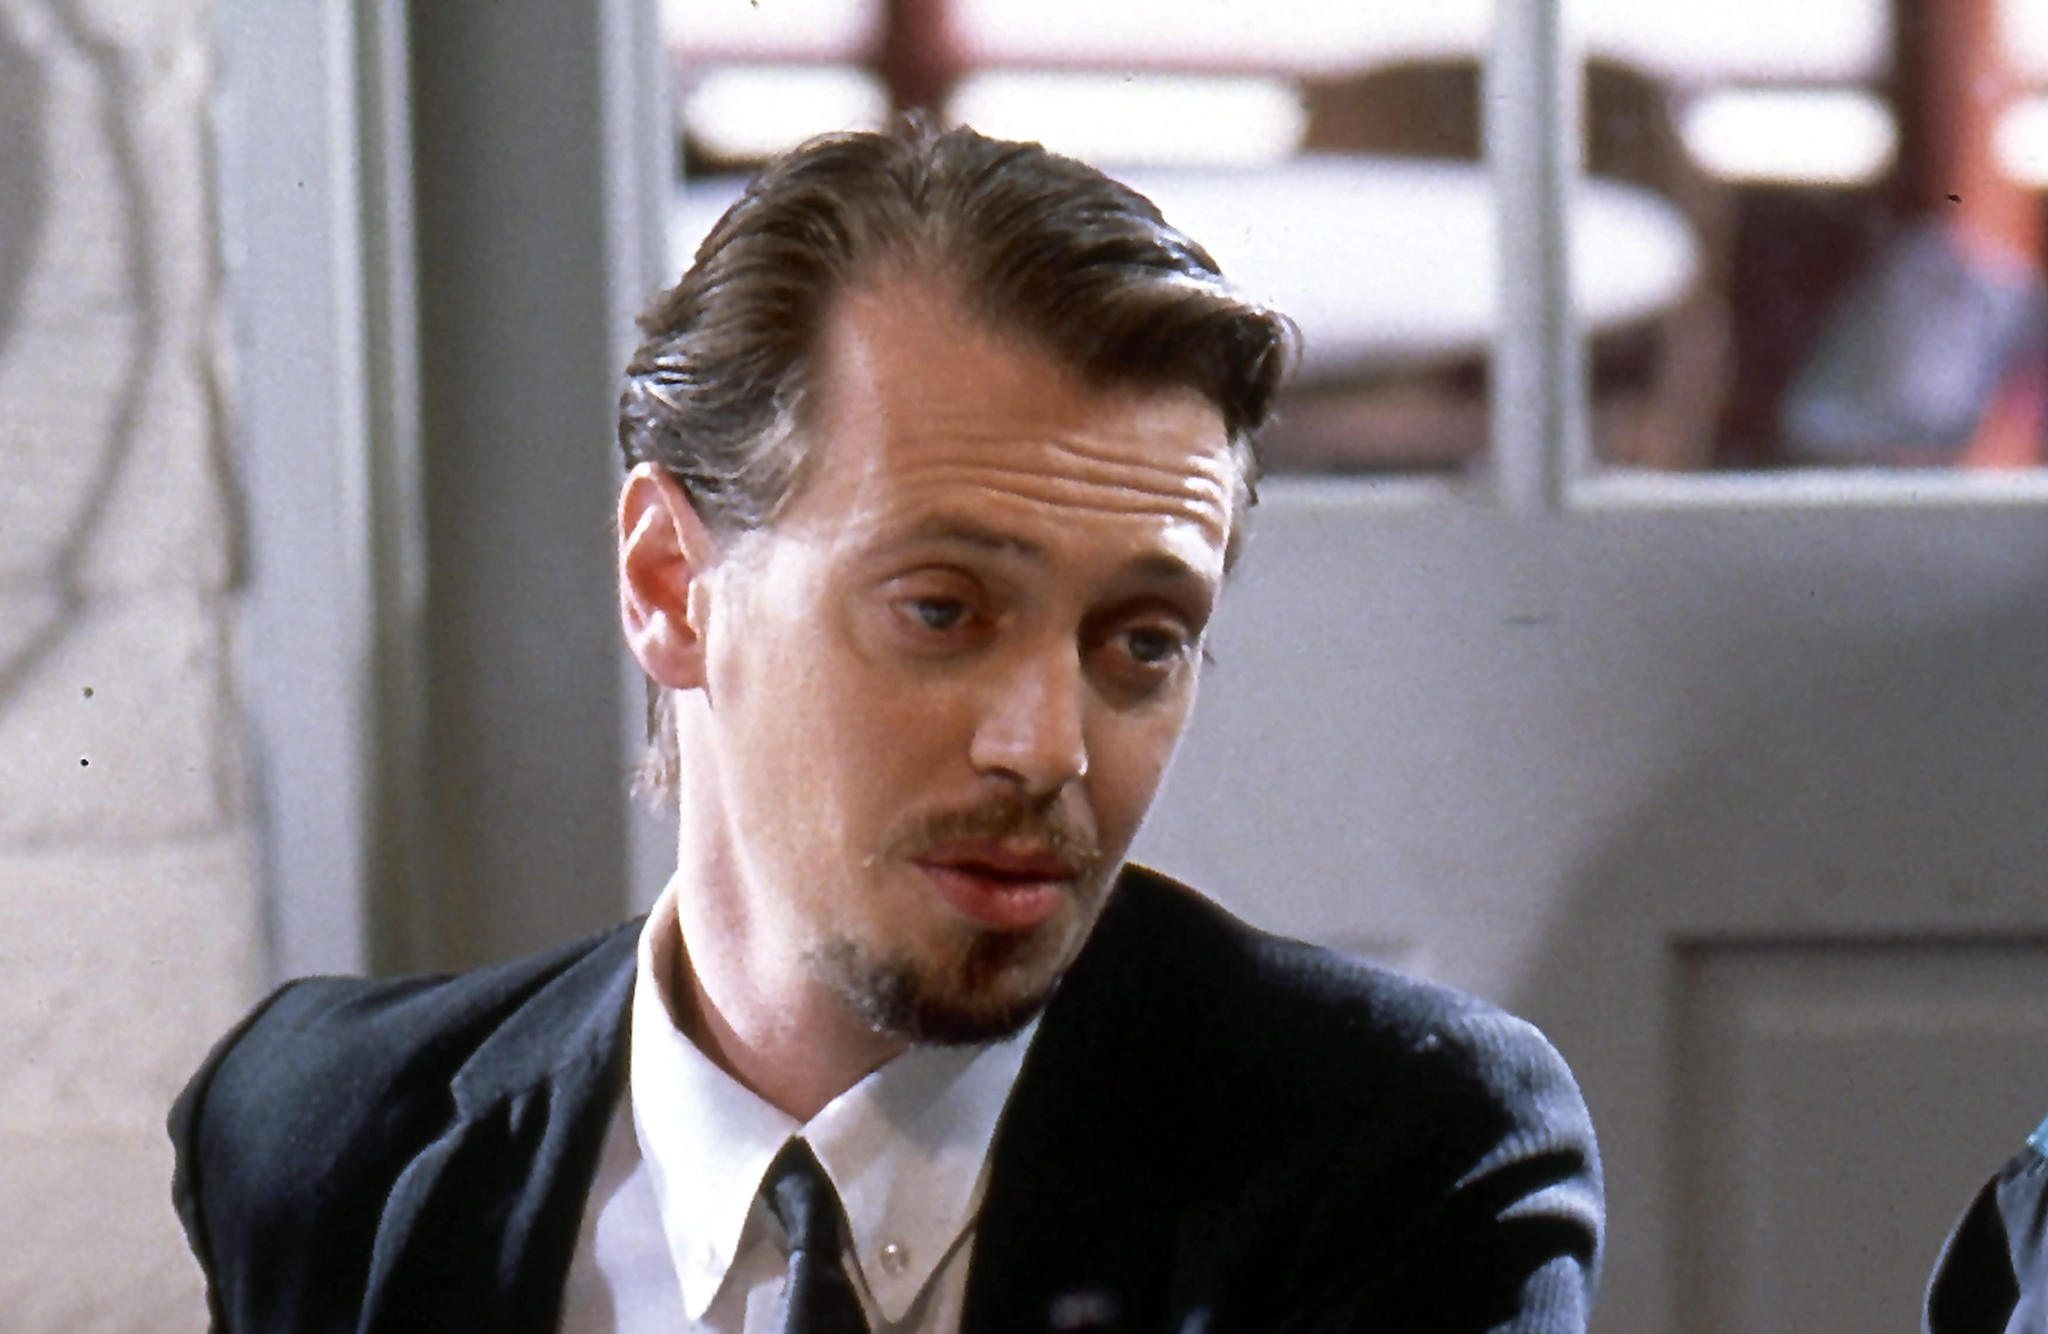If this character suddenly found himself in a magical world, what would his first reaction be? Get as creative as possible. Mr. Pink blinked as the café around him shimmered and transformed into an ethereal forest bathed in twilight. The soft glow of luminescent flowers illuminated a winding path ahead. For a moment, he questioned his sanity, but years of high-stakes situations had taught him to adapt quickly. "What the..." he muttered, rising from his seat. He noticed his black suit had inexplicably changed to a flowing cloak adorned with mysterious symbols. Intrigued yet cautious, he began to explore, his mind racing to devise a strategy for survival in this new, enchanted realm. Magical creatures fluttered around him, and a whispering voice beckoned him deeper into the forest. Mr. Pink's eyes narrowed with determination. "Looks like I've got a new mission," he said with a smirk, ready to face the unknown challenges ahead. 